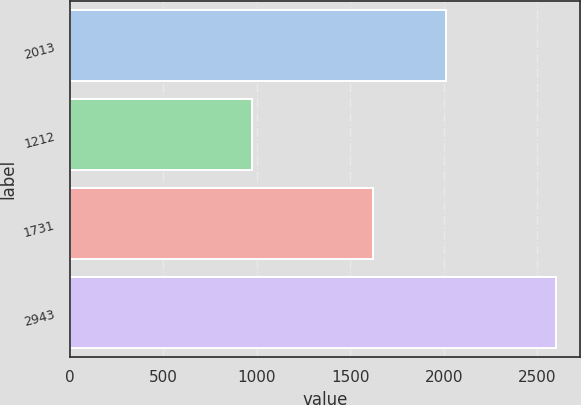Convert chart to OTSL. <chart><loc_0><loc_0><loc_500><loc_500><bar_chart><fcel>2013<fcel>1212<fcel>1731<fcel>2943<nl><fcel>2011<fcel>975<fcel>1622<fcel>2597<nl></chart> 